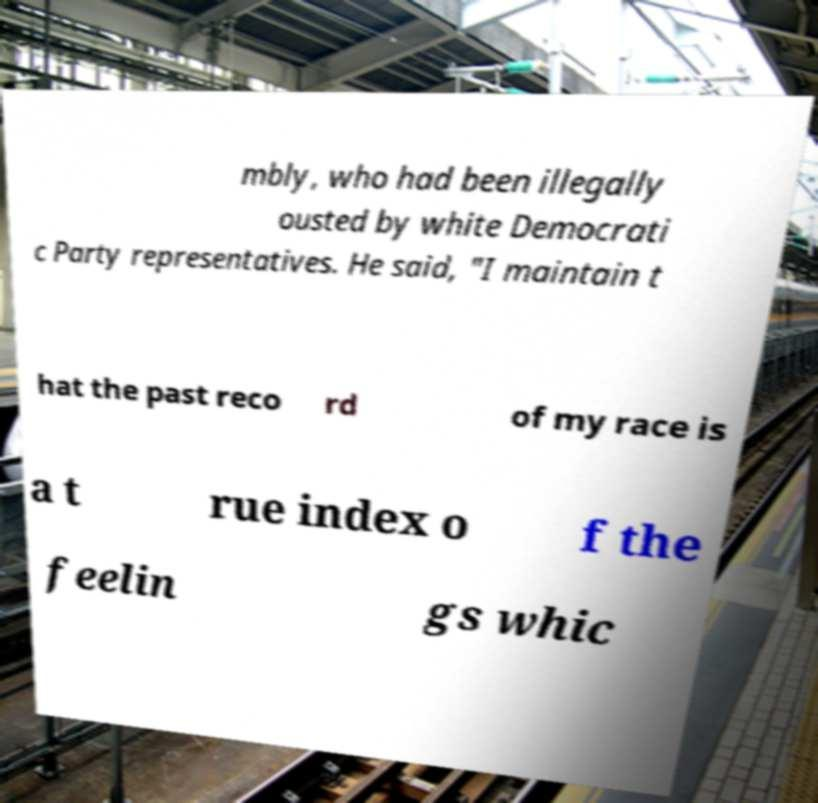For documentation purposes, I need the text within this image transcribed. Could you provide that? mbly, who had been illegally ousted by white Democrati c Party representatives. He said, "I maintain t hat the past reco rd of my race is a t rue index o f the feelin gs whic 